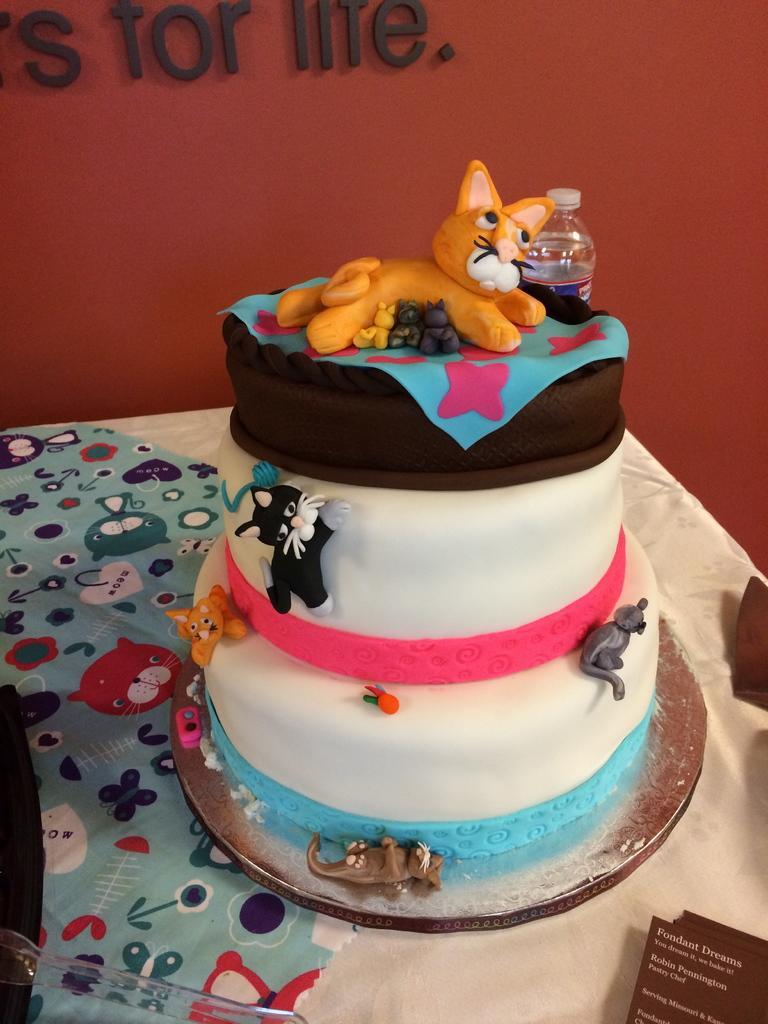In one or two sentences, can you explain what this image depicts? In this picture there is a cake placed on the table. The cake is in three steps. There is a bottle and in the background there is a wall. 